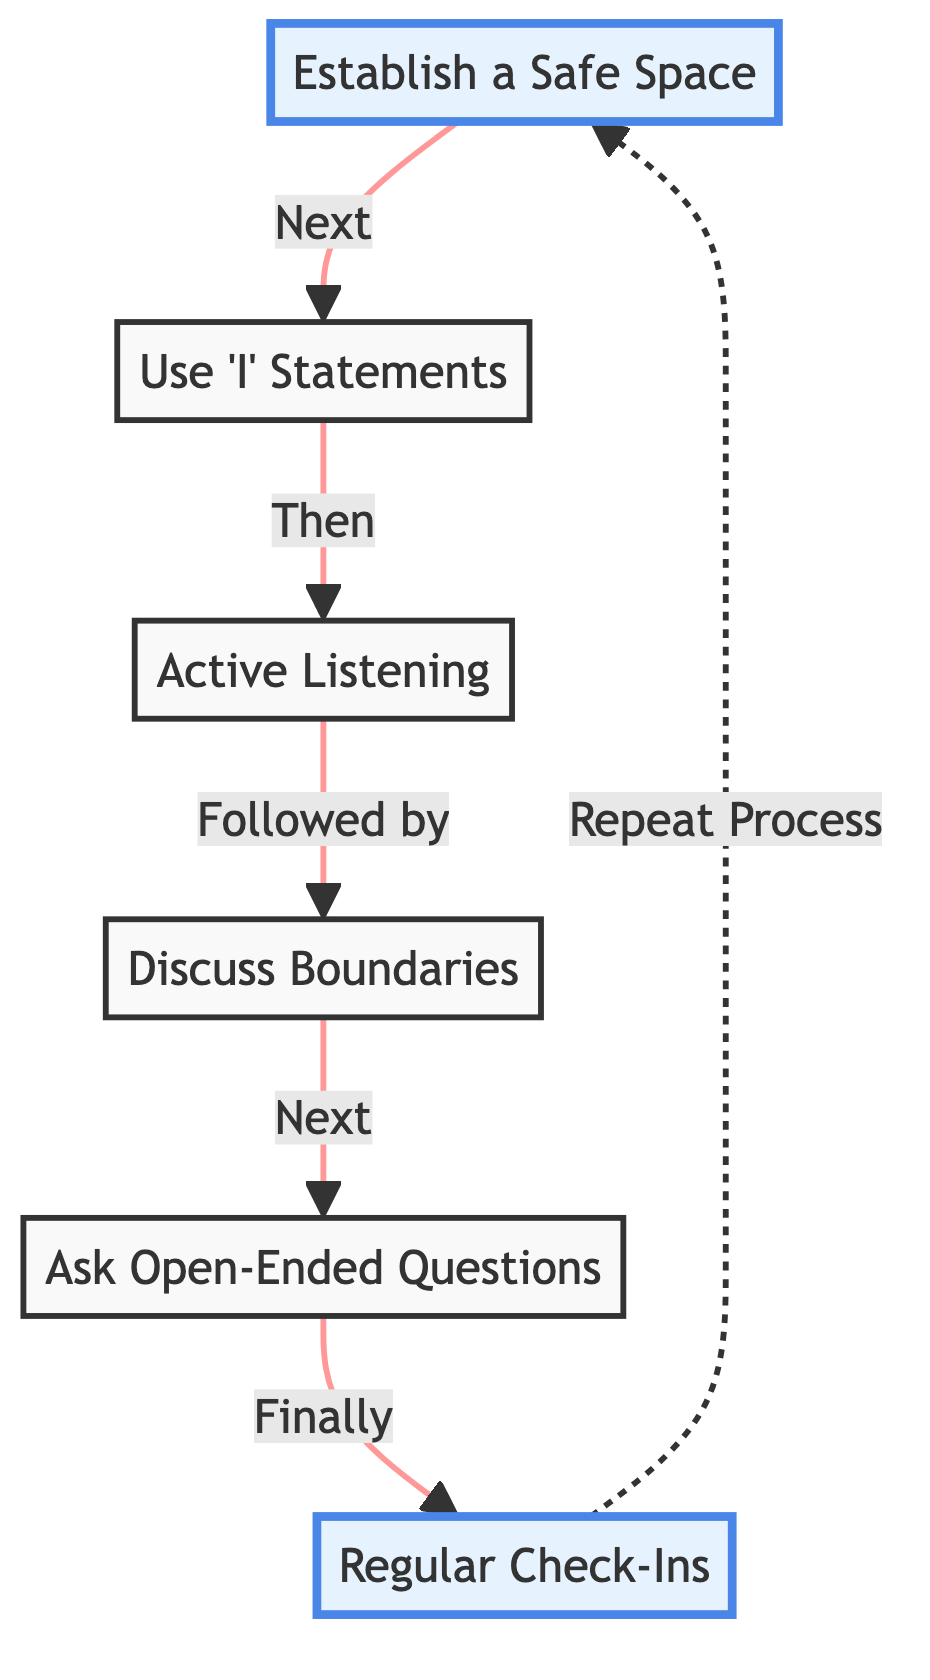What is the first step in enhancing sexual communication? The first step in the diagram is "Establish a Safe Space," which indicates the initial action to create a supportive environment for communication.
Answer: Establish a Safe Space How many nodes are in the flowchart? By counting the individual steps represented, we find there are 6 nodes in the diagram that illustrate different techniques for enhancing sexual communication.
Answer: 6 Which statement comes immediately after "Use 'I' Statements"? Following "Use 'I' Statements," the next action according to the flow of the diagram is "Active Listening." This illustrates the sequential process mentioned in the chart.
Answer: Active Listening What type of questions are encouraged to promote deeper discussion? The flowchart specifically mentions "Ask Open-Ended Questions" as the technique that encourages dialogue and deeper discussion among partners.
Answer: Ask Open-Ended Questions What action follows after "Regular Check-Ins"? The diagram indicates that after "Regular Check-Ins," the process should "Repeat Process," which signifies it's a cyclical approach to improve communication continuously.
Answer: Repeat Process What are partners encouraged to discuss following "Active Listening"? According to the flow of the diagram, after "Active Listening," the next topic to be addressed is "Discuss Boundaries," suggesting a progression in the conversation topics.
Answer: Discuss Boundaries What connects "Regular Check-Ins" back to "Establish a Safe Space"? The flowchart illustrates that "Regular Check-Ins" leads back to "Establish a Safe Space" through a dashed arrow, indicating a cyclical relationship in the enhancing techniques.
Answer: Repeat Process 